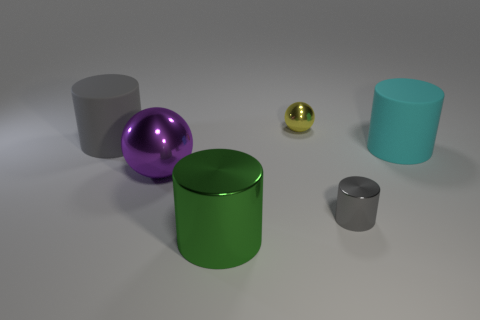There is another shiny object that is the same shape as the large purple metallic object; what size is it?
Your answer should be compact. Small. Do the tiny sphere and the tiny object that is in front of the yellow ball have the same color?
Give a very brief answer. No. Is the color of the tiny ball the same as the small cylinder?
Provide a short and direct response. No. Are there fewer large brown metallic cylinders than balls?
Ensure brevity in your answer.  Yes. How many other things are there of the same color as the big metallic sphere?
Your response must be concise. 0. How many matte cylinders are there?
Ensure brevity in your answer.  2. Are there fewer metal balls that are in front of the big gray matte object than shiny things?
Your answer should be very brief. Yes. Does the gray cylinder in front of the cyan rubber cylinder have the same material as the green thing?
Give a very brief answer. Yes. What shape is the rubber thing on the left side of the object in front of the metal cylinder to the right of the green metal object?
Your answer should be very brief. Cylinder. Is there a gray metallic sphere that has the same size as the purple object?
Keep it short and to the point. No. 